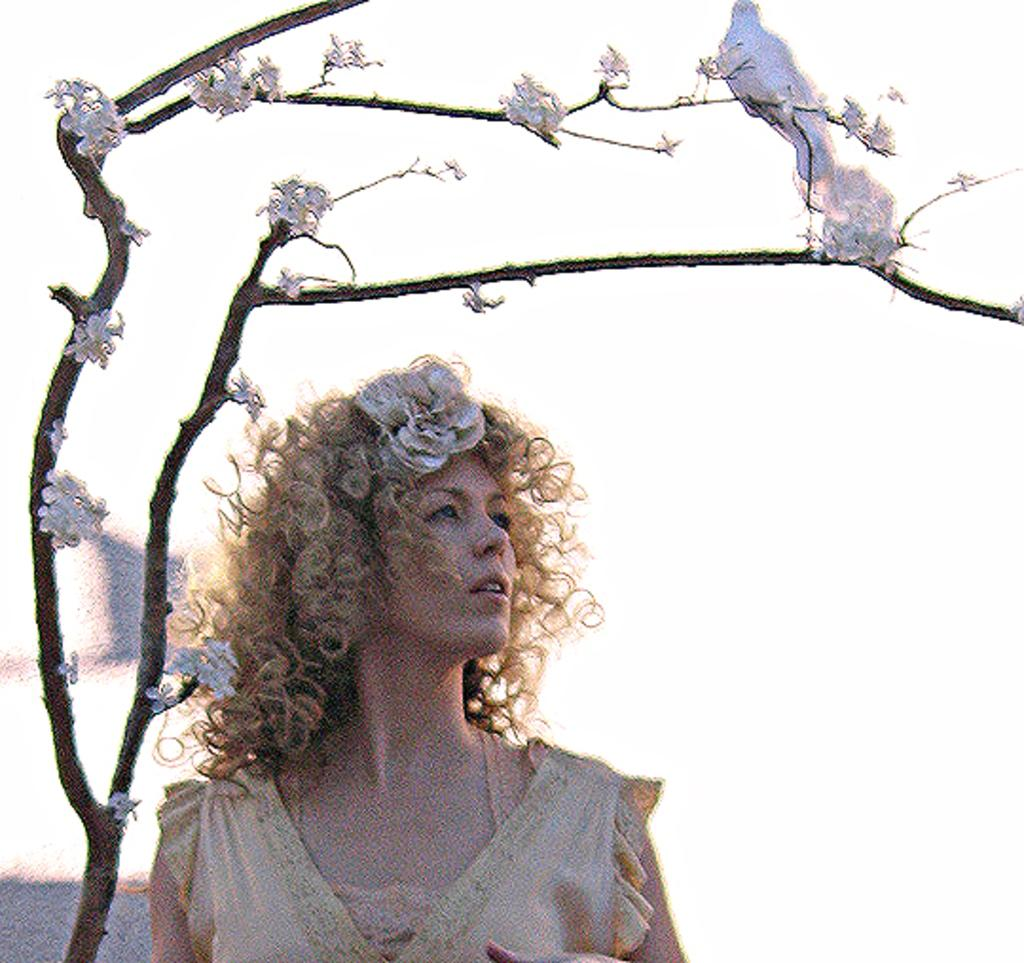Who is present in the image? There is a woman in the image. What is located behind the woman? There is a bird behind the woman. What type of vegetation can be seen in the image? There are flowers on a branch in the image. How many children are playing on the mountain in the image? There is no mountain or children present in the image. What page is the bird on in the image? The image is not a book or page, so there is no page for the bird to be on. 